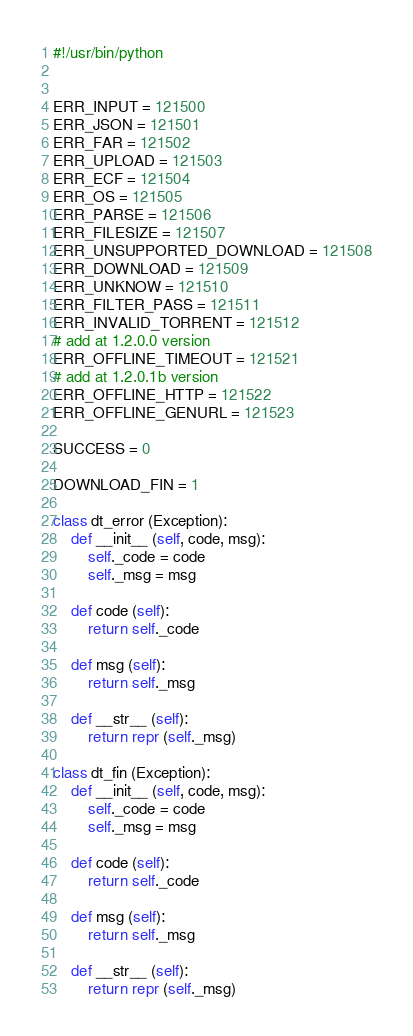Convert code to text. <code><loc_0><loc_0><loc_500><loc_500><_Python_>#!/usr/bin/python


ERR_INPUT = 121500
ERR_JSON = 121501
ERR_FAR = 121502
ERR_UPLOAD = 121503
ERR_ECF = 121504
ERR_OS = 121505
ERR_PARSE = 121506
ERR_FILESIZE = 121507
ERR_UNSUPPORTED_DOWNLOAD = 121508
ERR_DOWNLOAD = 121509
ERR_UNKNOW = 121510
ERR_FILTER_PASS = 121511
ERR_INVALID_TORRENT = 121512
# add at 1.2.0.0 version
ERR_OFFLINE_TIMEOUT = 121521
# add at 1.2.0.1b version
ERR_OFFLINE_HTTP = 121522
ERR_OFFLINE_GENURL = 121523

SUCCESS = 0

DOWNLOAD_FIN = 1

class dt_error (Exception):
    def __init__ (self, code, msg):
        self._code = code
        self._msg = msg

    def code (self):
        return self._code

    def msg (self):
        return self._msg

    def __str__ (self):
        return repr (self._msg)

class dt_fin (Exception):
    def __init__ (self, code, msg):
        self._code = code
        self._msg = msg

    def code (self):
        return self._code

    def msg (self):
        return self._msg

    def __str__ (self):
        return repr (self._msg)
</code> 